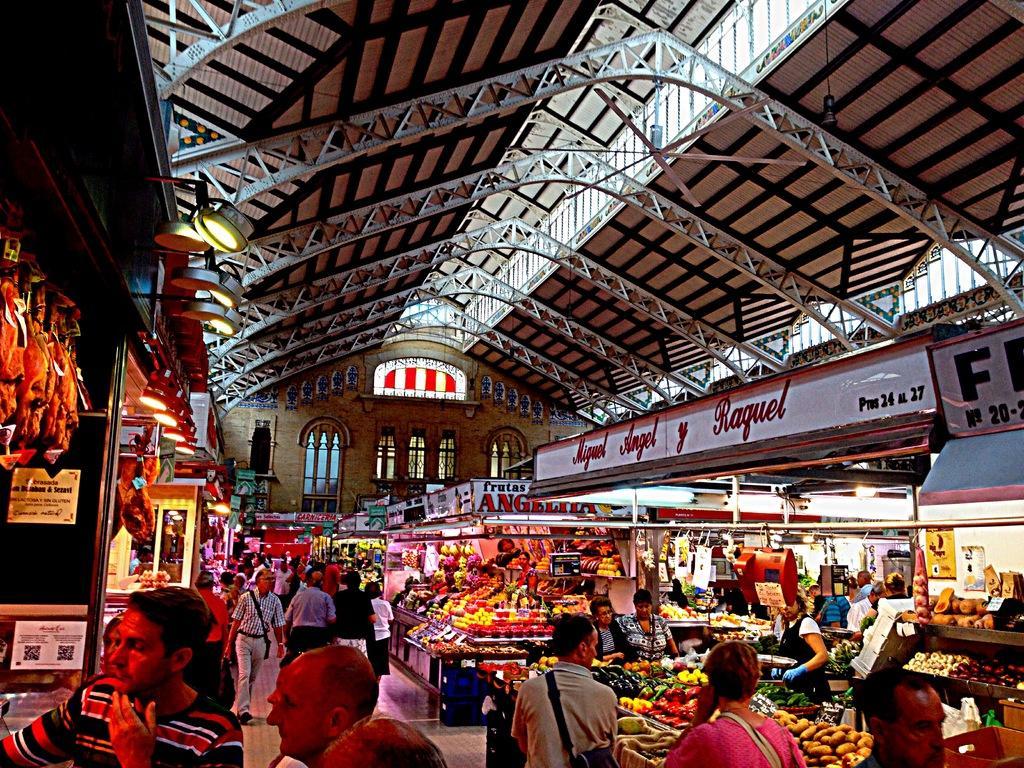Can you describe this image briefly? In the image we can see there are many people around, they are wearing clothes, this is a handbag, poster and light. There are fruits and vegetables, These are the windows of the building, this is a footpath. 